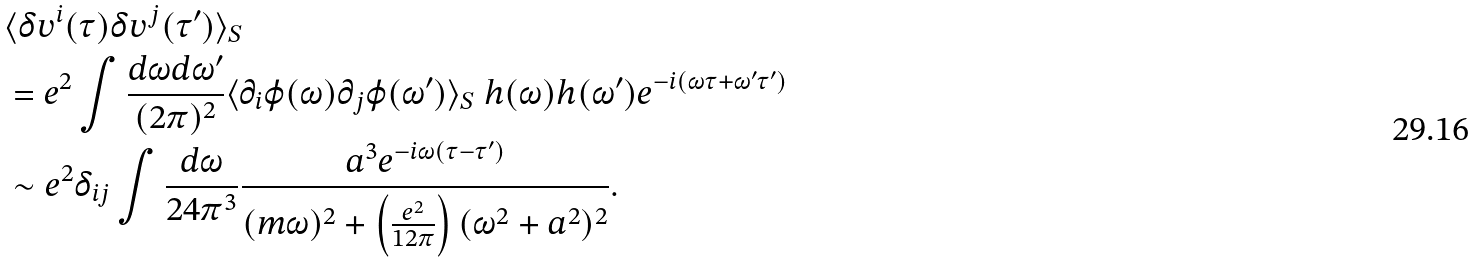Convert formula to latex. <formula><loc_0><loc_0><loc_500><loc_500>& \langle \delta v ^ { i } ( \tau ) \delta v ^ { j } ( \tau ^ { \prime } ) \rangle _ { S } \\ & = e ^ { 2 } \int \frac { d \omega d \omega ^ { \prime } } { ( 2 \pi ) ^ { 2 } } \langle \partial _ { i } \varphi ( \omega ) \partial _ { j } \varphi ( \omega ^ { \prime } ) \rangle _ { S } \ h ( \omega ) h ( \omega ^ { \prime } ) e ^ { - i ( \omega \tau + \omega ^ { \prime } \tau ^ { \prime } ) } \\ & \sim e ^ { 2 } \delta _ { i j } \int \frac { d \omega } { 2 4 \pi ^ { 3 } } \frac { a ^ { 3 } e ^ { - i \omega ( \tau - \tau ^ { \prime } ) } } { ( m \omega ) ^ { 2 } + \left ( \frac { e ^ { 2 } } { 1 2 \pi } \right ) ( \omega ^ { 2 } + a ^ { 2 } ) ^ { 2 } } .</formula> 